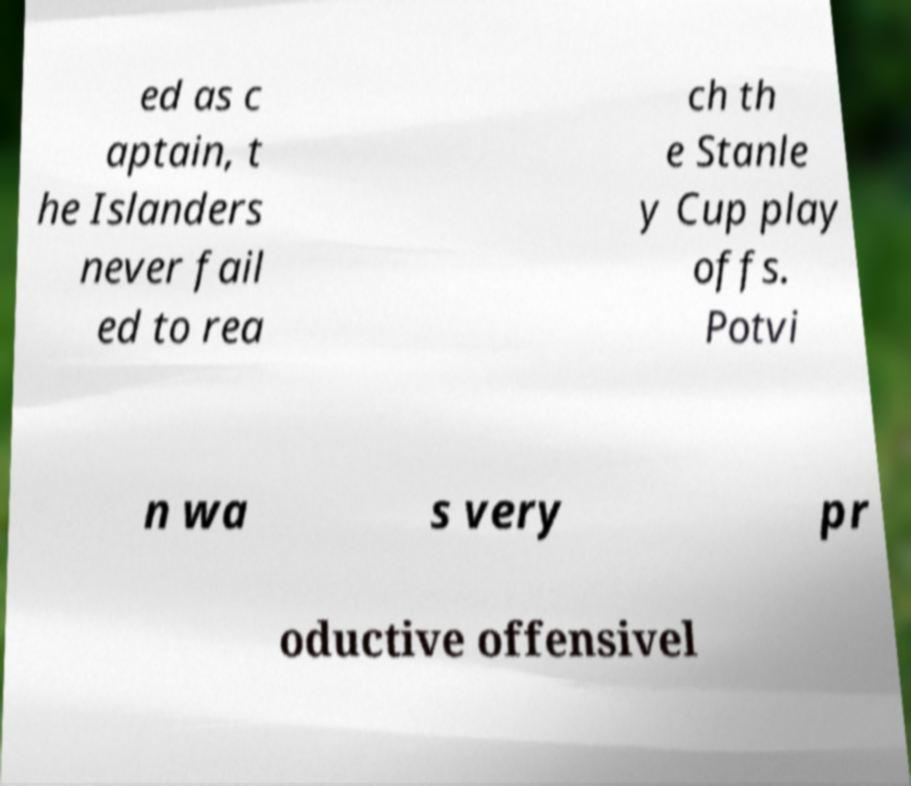Can you read and provide the text displayed in the image?This photo seems to have some interesting text. Can you extract and type it out for me? ed as c aptain, t he Islanders never fail ed to rea ch th e Stanle y Cup play offs. Potvi n wa s very pr oductive offensivel 